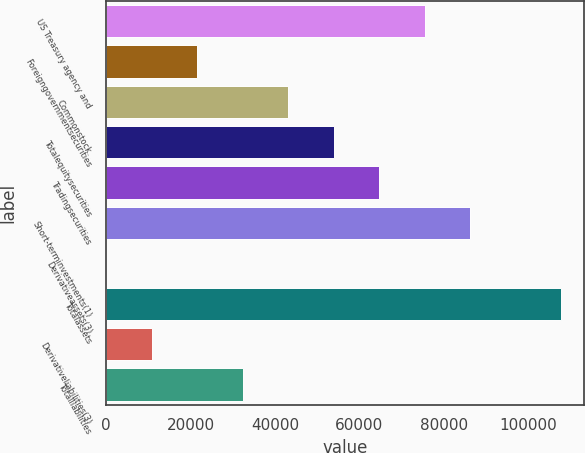<chart> <loc_0><loc_0><loc_500><loc_500><bar_chart><fcel>US Treasury agency and<fcel>Foreigngovernmentsecurities<fcel>Commonstock<fcel>Totalequitysecurities<fcel>Tradingsecurities<fcel>Short-terminvestments(1)<fcel>Derivativeassets(3)<fcel>Totalassets<fcel>Derivativeliabilities(3)<fcel>Totalliabilities<nl><fcel>75549.3<fcel>21624.8<fcel>43194.6<fcel>53979.5<fcel>64764.4<fcel>86334.2<fcel>55<fcel>107904<fcel>10839.9<fcel>32409.7<nl></chart> 